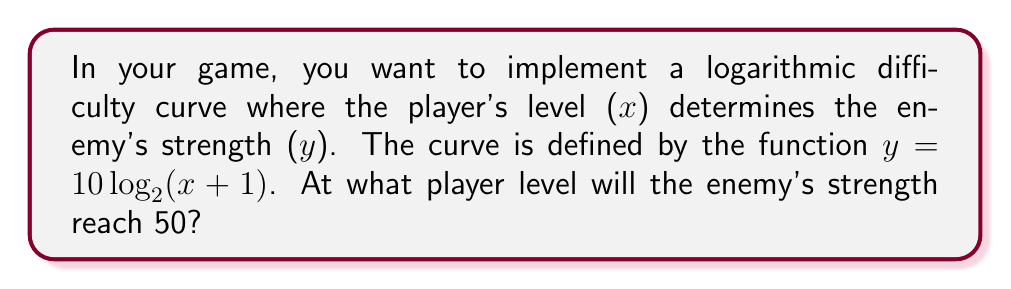Can you answer this question? Let's approach this step-by-step:

1) We're given the function $y = 10 \log_2(x + 1)$, where:
   $y$ is the enemy's strength
   $x$ is the player's level

2) We want to find $x$ when $y = 50$. So, let's substitute this:

   $50 = 10 \log_2(x + 1)$

3) First, divide both sides by 10:

   $5 = \log_2(x + 1)$

4) Now, we can use the definition of logarithms to rewrite this as an exponential equation:

   $2^5 = x + 1$

5) Calculate $2^5$:

   $32 = x + 1$

6) Subtract 1 from both sides:

   $31 = x$

Therefore, the player level at which the enemy's strength will reach 50 is 31.
Answer: 31 